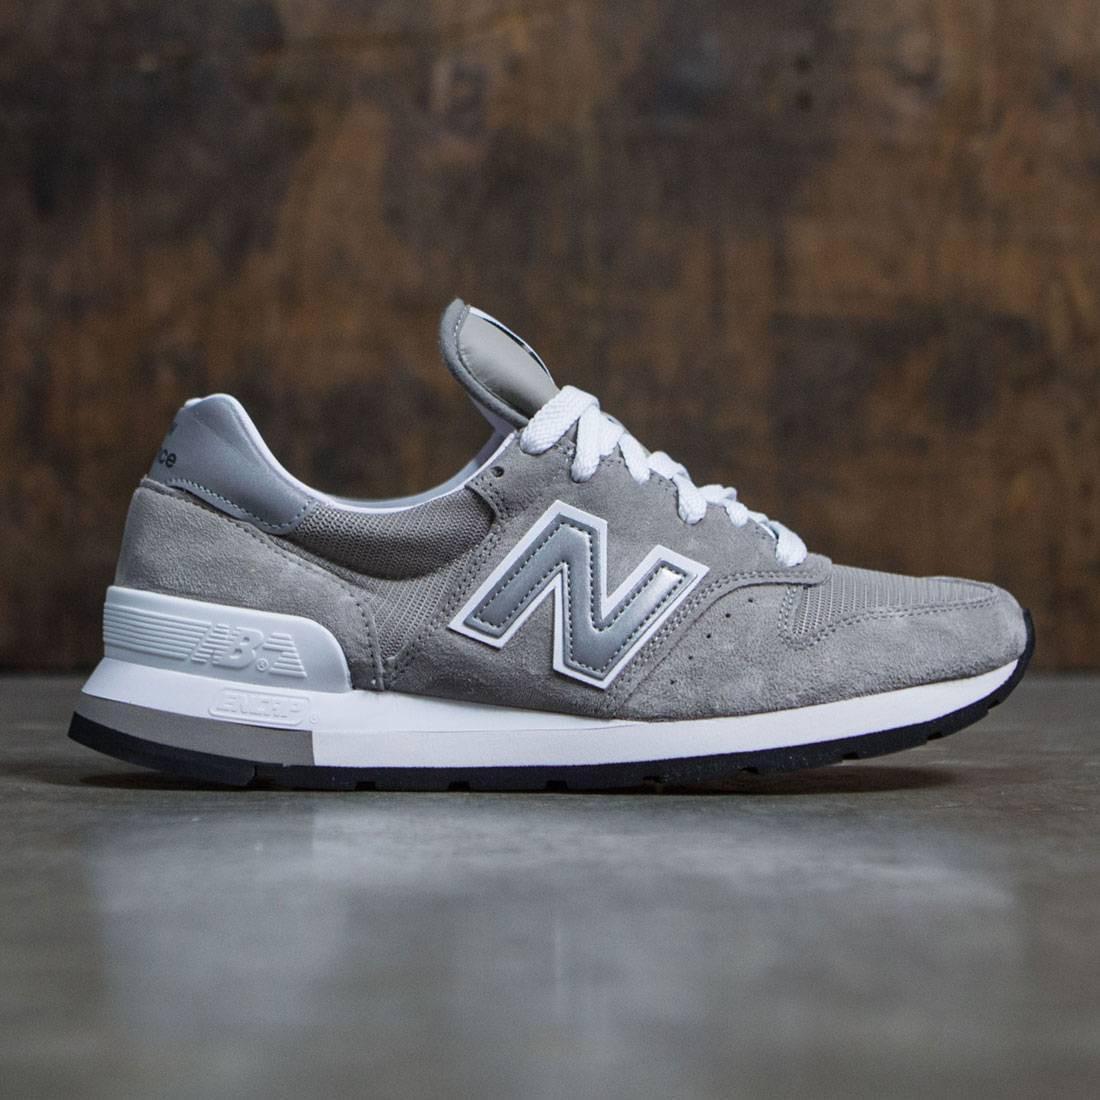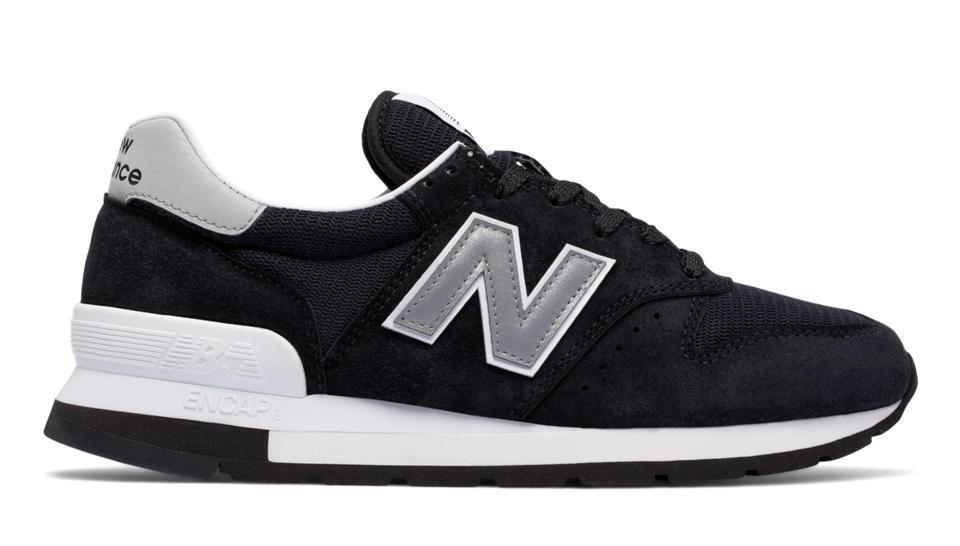The first image is the image on the left, the second image is the image on the right. For the images shown, is this caption "Left and right images contain the same number of sneakers displayed in the same position, and no human legs are depicted anywhere in either image." true? Answer yes or no. Yes. The first image is the image on the left, the second image is the image on the right. Examine the images to the left and right. Is the description "The shoes in each of the images are depicted in an advertisement." accurate? Answer yes or no. No. 